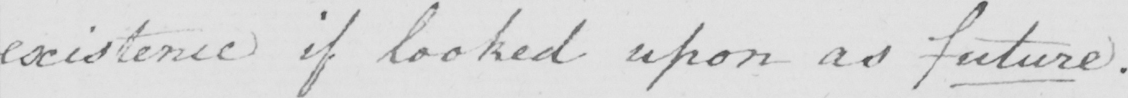Can you read and transcribe this handwriting? existence if looked upon as future . 